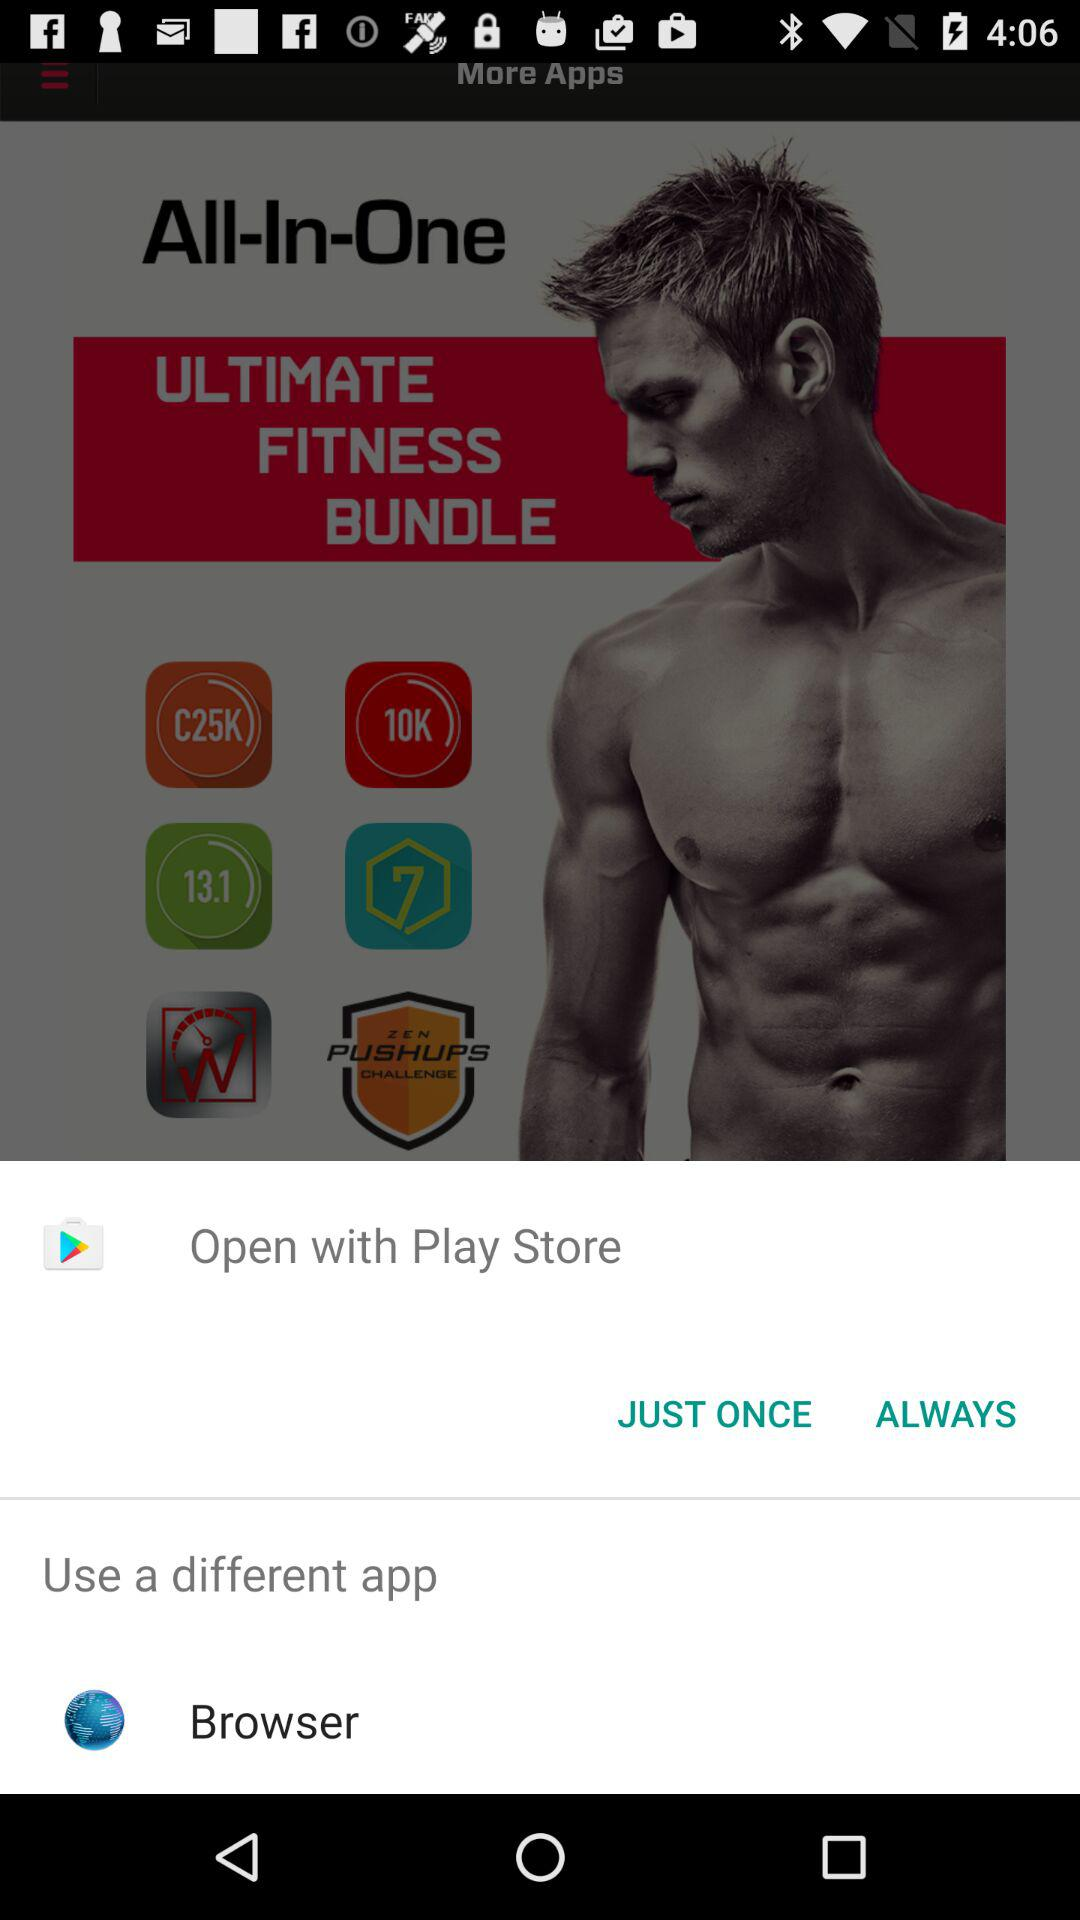With what apps can we open this? You can open with "Open with Play Store" and "Browser". 